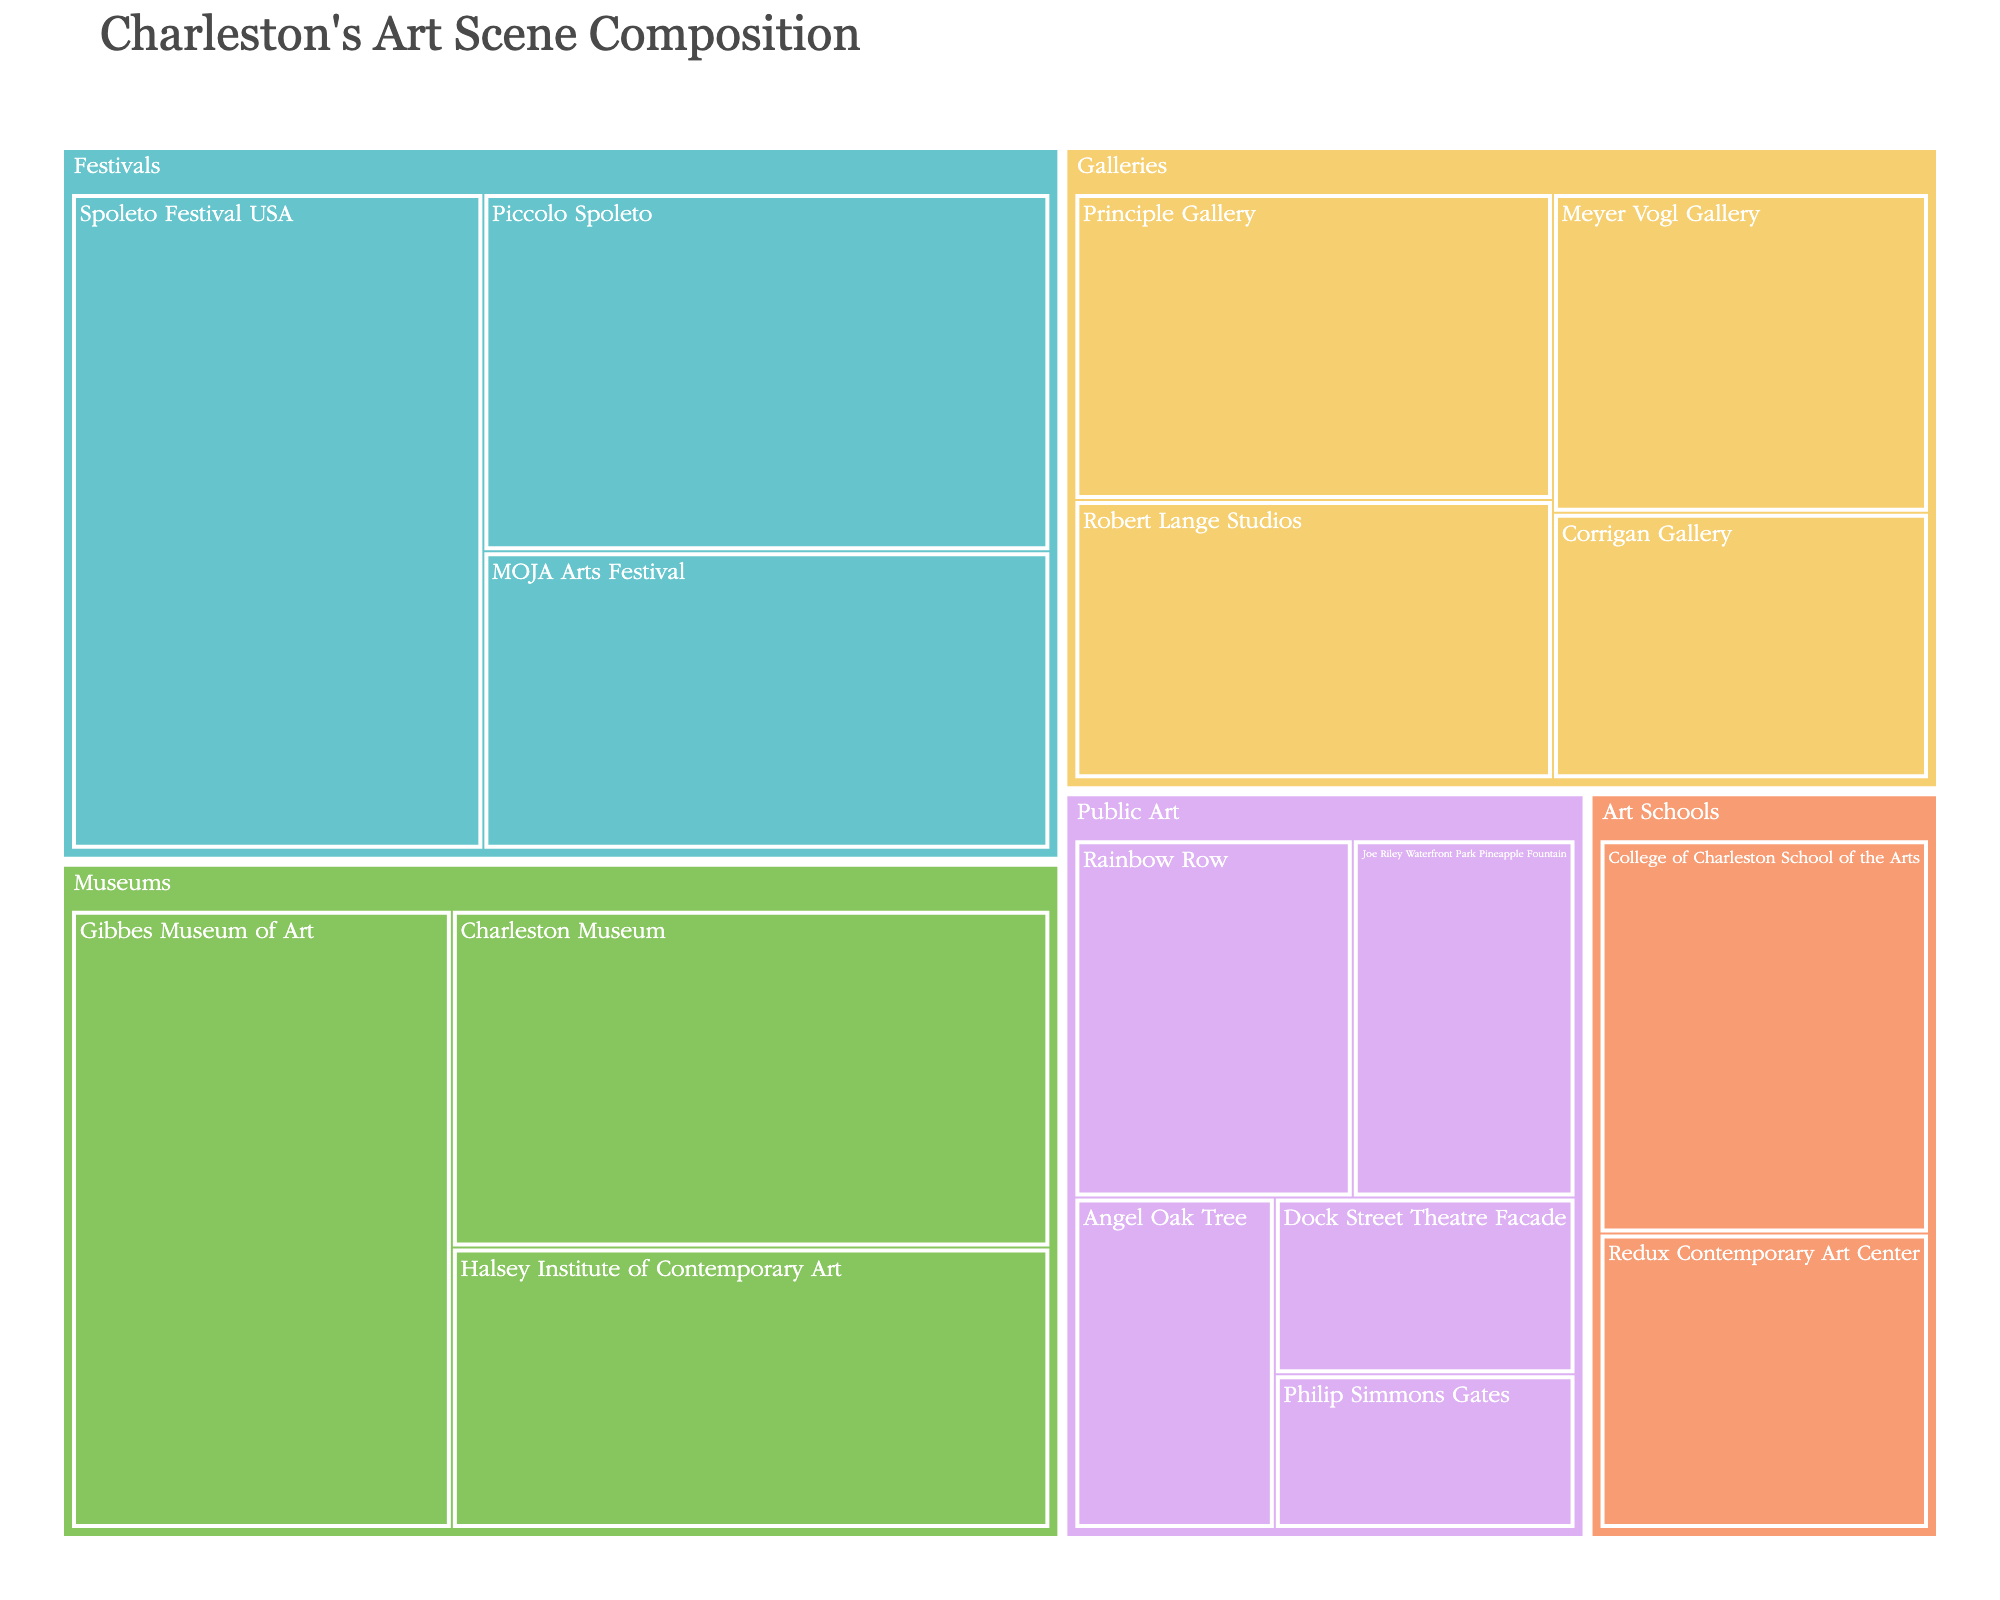What's the title of the Treemap? The title is usually at the top of the plot and helps with understanding the overall topic.
Answer: Charleston's Art Scene Composition Which subcategory within Galleries has the highest value? Look at the subcategories under Galleries and compare their values.
Answer: Principle Gallery What is the combined value of all Museums? Sum the values of all subcategories under Museums: Gibbes Museum of Art (35), Charleston Museum (30), and Halsey Institute of Contemporary Art (25). 35 + 30 + 25 = 90
Answer: 90 Which category has the smallest total value? Sum the values in each category and compare them. Galleries = 75, Museums = 90, Public Art = 52, Festivals = 95, Art Schools = 35. The smallest is Public Art (52).
Answer: Public Art How does the value of Spoleto Festival USA compare to the Philip Simmons Gates in Public Art? Directly compare the values of Spoleto Festival USA (40) and Philip Simmons Gates (7). 40 is greater than 7.
Answer: Spoleto Festival USA is greater What is the total value of all subcategories under Public Art? Add up the values of Rainbow Row (15), Joe Riley Waterfront Park Pineapple Fountain (12), Angel Oak Tree (10), Dock Street Theatre Facade (8), and Philip Simmons Gates (7). 15 + 12 + 10 + 8 + 7 = 52
Answer: 52 Which subcategory under Art Schools has the higher value? Compare the values of College of Charleston School of the Arts (20) and Redux Contemporary Art Center (15).
Answer: College of Charleston School of the Arts Which category has the highest representation in terms of value in the Treemap? Compare the total values of all categories. Galleries = 75, Museums = 90, Public Art = 52, Festivals = 95, Art Schools = 35. Festivals have the highest value (95).
Answer: Festivals What is the average value of subcategories within Galleries? Sum the values of all subcategories within Galleries and divide by the number of subcategories. (20 + 15 + 18 + 22) / 4 = 18.75
Answer: 18.75 What is the difference in value between the highest and lowest subcategories under Festivals? Identify the highest value (Spoleto Festival USA, 40) and the lowest value (MOJA Arts Festival, 25) under Festivals and subtract the lowest from the highest. 40 - 25 = 15
Answer: 15 